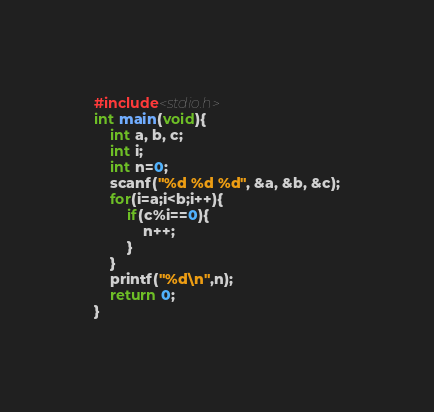Convert code to text. <code><loc_0><loc_0><loc_500><loc_500><_C_>#include<stdio.h>
int main(void){
    int a, b, c;
    int i;
    int n=0;
    scanf("%d %d %d", &a, &b, &c);
    for(i=a;i<b;i++){
        if(c%i==0){
            n++;
        }
    }
    printf("%d\n",n);
    return 0;
}
</code> 